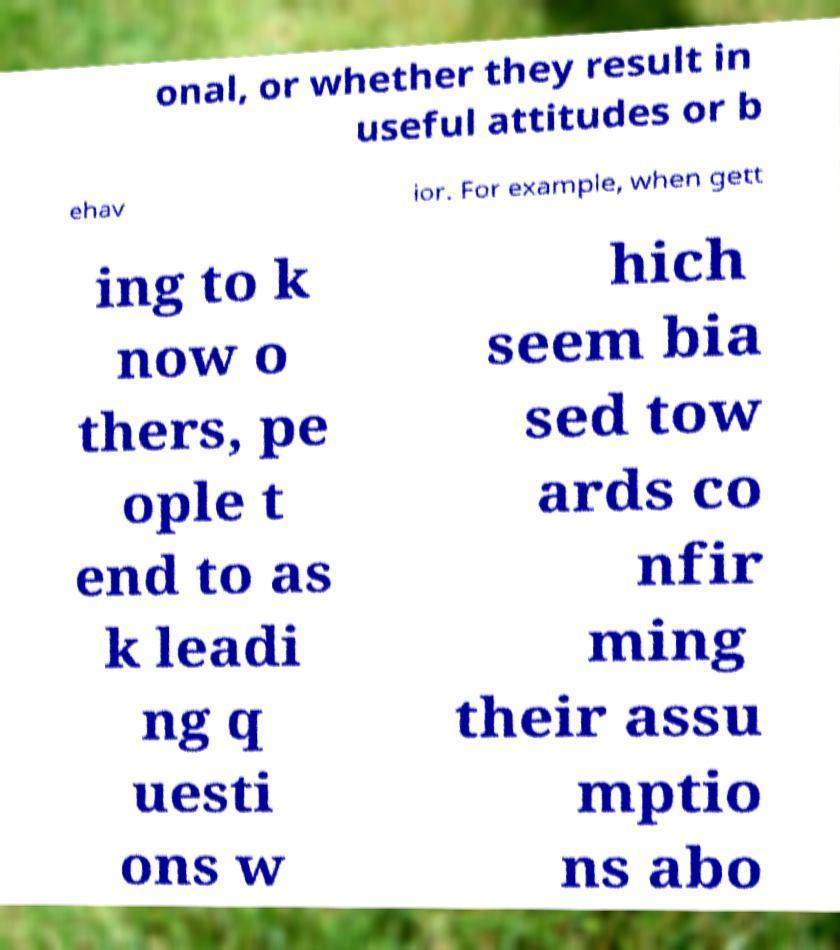Could you assist in decoding the text presented in this image and type it out clearly? onal, or whether they result in useful attitudes or b ehav ior. For example, when gett ing to k now o thers, pe ople t end to as k leadi ng q uesti ons w hich seem bia sed tow ards co nfir ming their assu mptio ns abo 